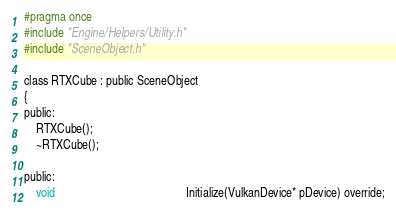Convert code to text. <code><loc_0><loc_0><loc_500><loc_500><_C_>#pragma once
#include "Engine/Helpers/Utility.h"
#include "SceneObject.h"

class RTXCube : public SceneObject
{
public:
    RTXCube();
    ~RTXCube();

public:
    void                                            Initialize(VulkanDevice* pDevice) override;</code> 